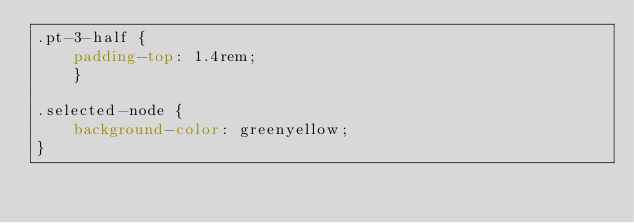<code> <loc_0><loc_0><loc_500><loc_500><_CSS_>.pt-3-half {
    padding-top: 1.4rem;
    }
    
.selected-node {
    background-color: greenyellow;
}</code> 